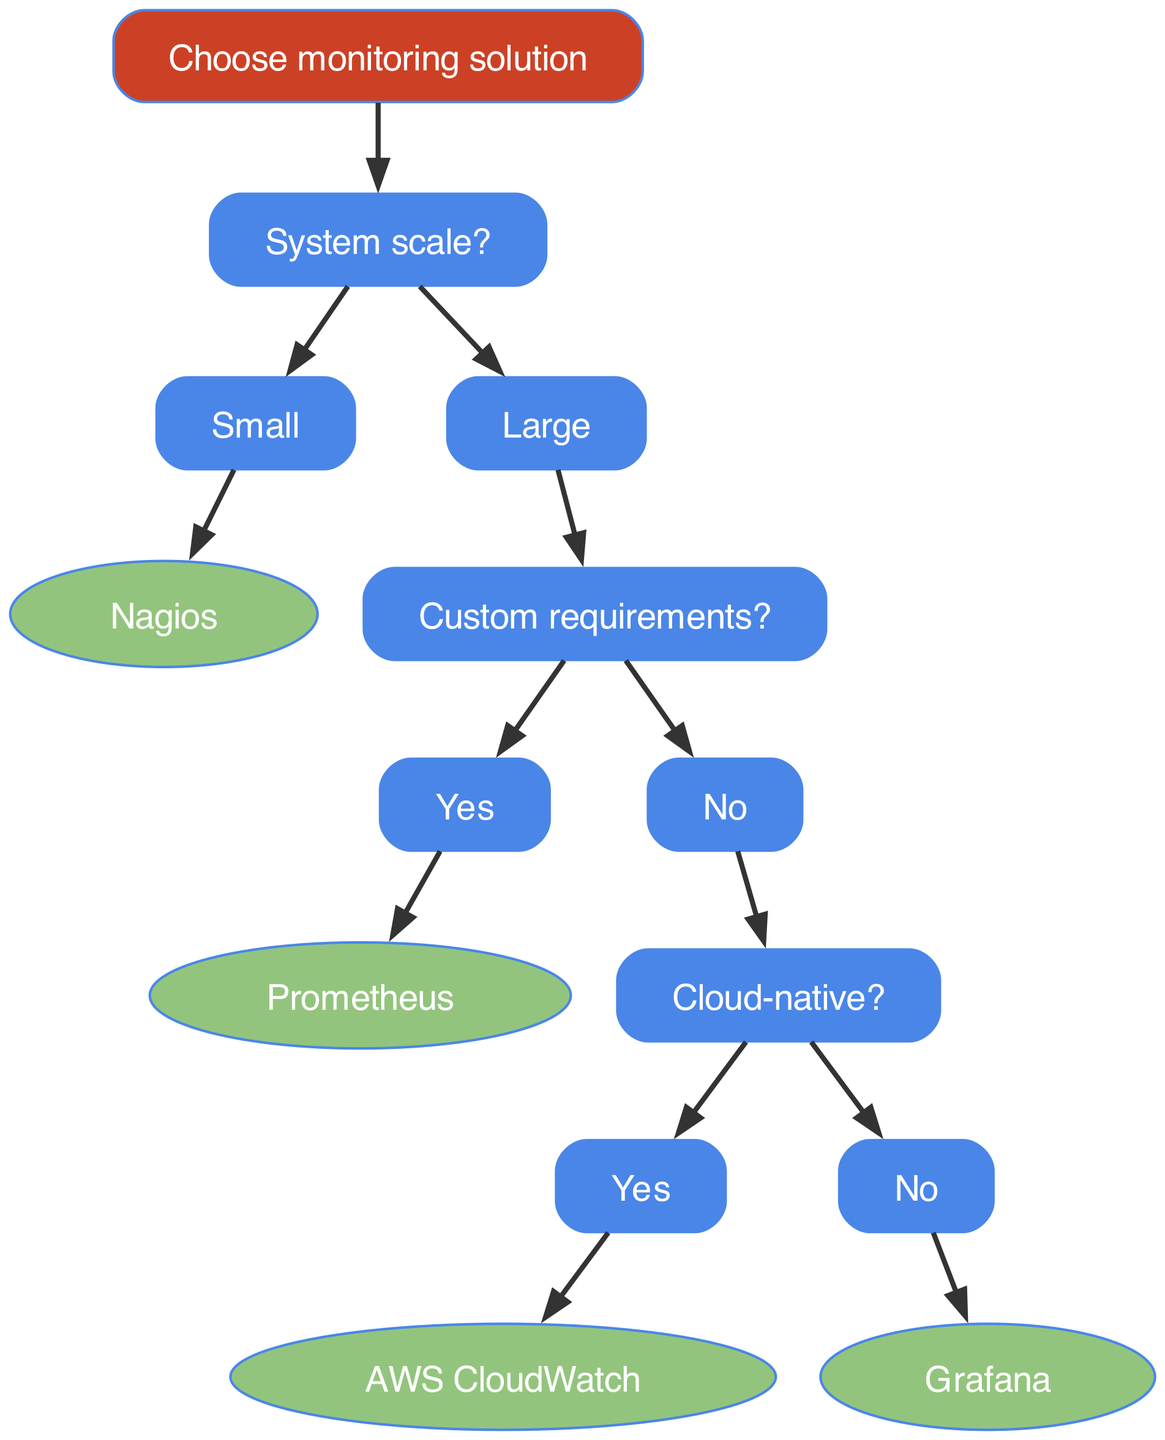What is the root node of the diagram? The root node is "Choose monitoring solution," which is depicted at the top of the decision tree.
Answer: Choose monitoring solution How many main branches are there from the root node? The diagram shows two main branches stemming from the root node: one for "Small" and the other for "Large." Thus, the total is two.
Answer: 2 What monitoring solution is suggested for a small system? Following the path from the "Small" node leads directly to the "Nagios" node, indicating that Nagios is the solution for small systems.
Answer: Nagios What is the monitoring solution if the system is large and has no custom requirements? For a large system with no custom requirements, we first follow to the "Cloud-native?" node, and if "No," we end at the "Grafana" node. Thus, the solution is Grafana.
Answer: Grafana If the system is large and cloud-native, what is the recommended monitoring solution? From the "Large" node, we go to "Cloud-native?" and then follow the path labeled "Yes" to arrive at "AWS CloudWatch," which is the recommended solution for this scenario.
Answer: AWS CloudWatch What solution is recommended for a large system with custom requirements? The path for a large system with custom requirements leads us directly to the "Prometheus" node, indicating that Prometheus is the solution for such systems.
Answer: Prometheus How many total nodes are there in the diagram? Counting all nodes involved, there are a total of eight nodes in the diagram, including both the branch nodes and leaf nodes.
Answer: 8 What is the first question addressed in the decision tree? The decision tree begins with the question "System scale?" which is the first branch decision made after the root.
Answer: System scale? What does the node "Yes" under "Custom requirements?" lead to? The node "Yes" under "Custom requirements?" leads to the "Prometheus" node, hence it specifies that if custom requirements exist, Prometheus is the suggested solution.
Answer: Prometheus 